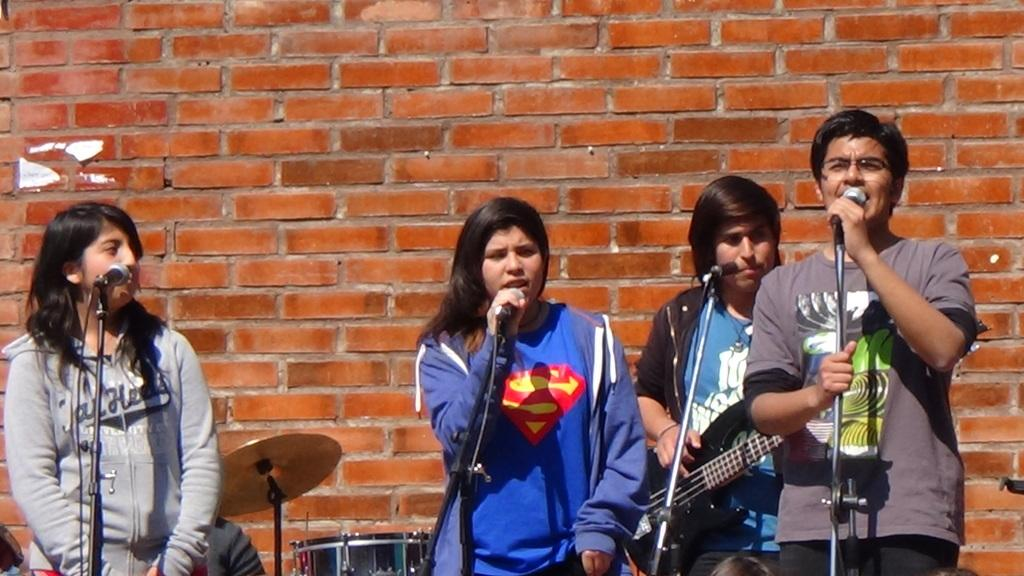How many musicians are present in the image? There are four musicians in the image. What are the musicians doing in the image? Three people are singing in front of a microphone, and one person is playing a guitar. What can be seen behind the musicians? There is a wall visible in the image. What other items are present in the image related to music? There are musical instruments in the image. What type of butter is being used by the musicians in the image? There is no butter present in the image; it is a scene of musicians playing music. 